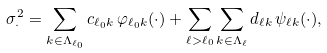<formula> <loc_0><loc_0><loc_500><loc_500>\sigma _ { \cdot } ^ { 2 } = \sum _ { k \in \Lambda _ { \ell _ { 0 } } } c _ { \ell _ { 0 } k } \, \varphi _ { \ell _ { 0 } k } ( \cdot ) + \sum _ { \ell > \ell _ { 0 } } \sum _ { k \in \Lambda _ { \ell } } d _ { \ell k } \, \psi _ { \ell k } ( \cdot ) ,</formula> 